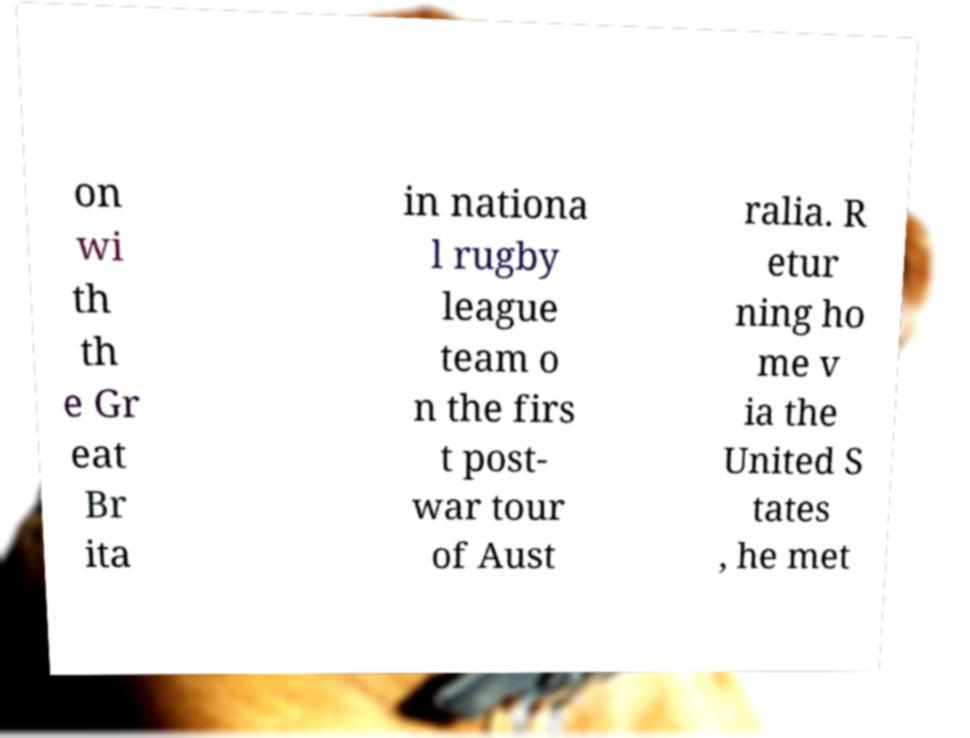Can you read and provide the text displayed in the image?This photo seems to have some interesting text. Can you extract and type it out for me? on wi th th e Gr eat Br ita in nationa l rugby league team o n the firs t post- war tour of Aust ralia. R etur ning ho me v ia the United S tates , he met 